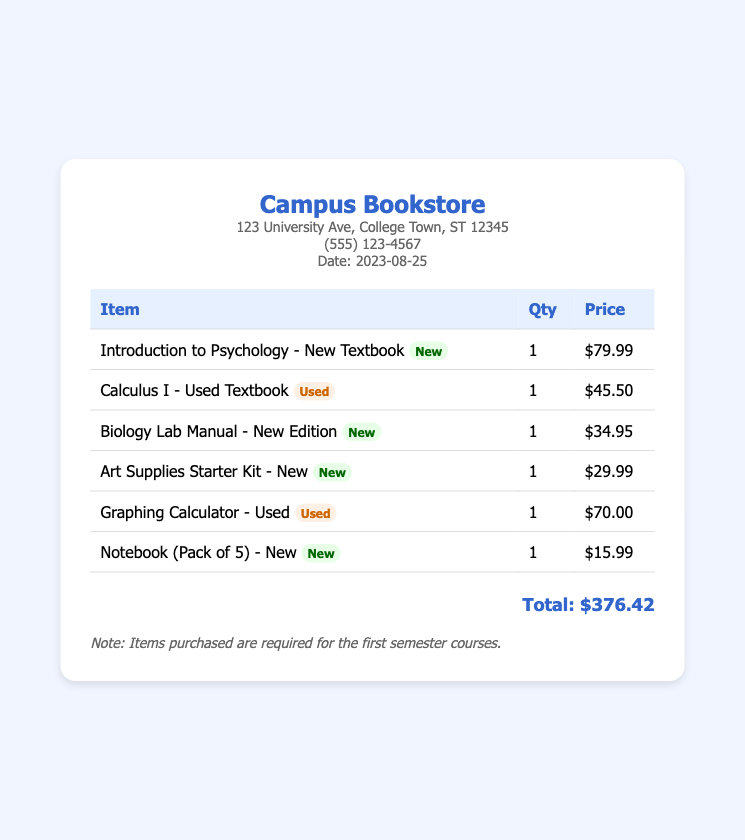What is the date of the purchase? The date of the purchase is indicated in the store details section of the document.
Answer: 2023-08-25 What is the total amount spent on textbooks and supplies? The total amount is stated at the bottom of the receipt in a clearly labeled section.
Answer: $376.42 How many new textbooks were purchased? The document lists the number of new items purchased, which can be counted from the item descriptions.
Answer: 4 What is the price of the "Graphing Calculator"? The price is displayed next to the item in the table of items purchased.
Answer: $70.00 Which item was listed as used? The item type can be identified from the provided information on the receipt.
Answer: Calculus I - Used Textbook What is the name of the store? The name of the store is prominently displayed at the top of the receipt.
Answer: Campus Bookstore What is the price of the "Notebook (Pack of 5)"? The price can be found next to this particular item in the itemized list.
Answer: $15.99 How many items were purchased in total? The total number of items can be determined by counting the quantity listed in the table for each item.
Answer: 6 What type of item is the "Biology Lab Manual"? The type is indicated next to the item in the description by an accompanying label.
Answer: New 